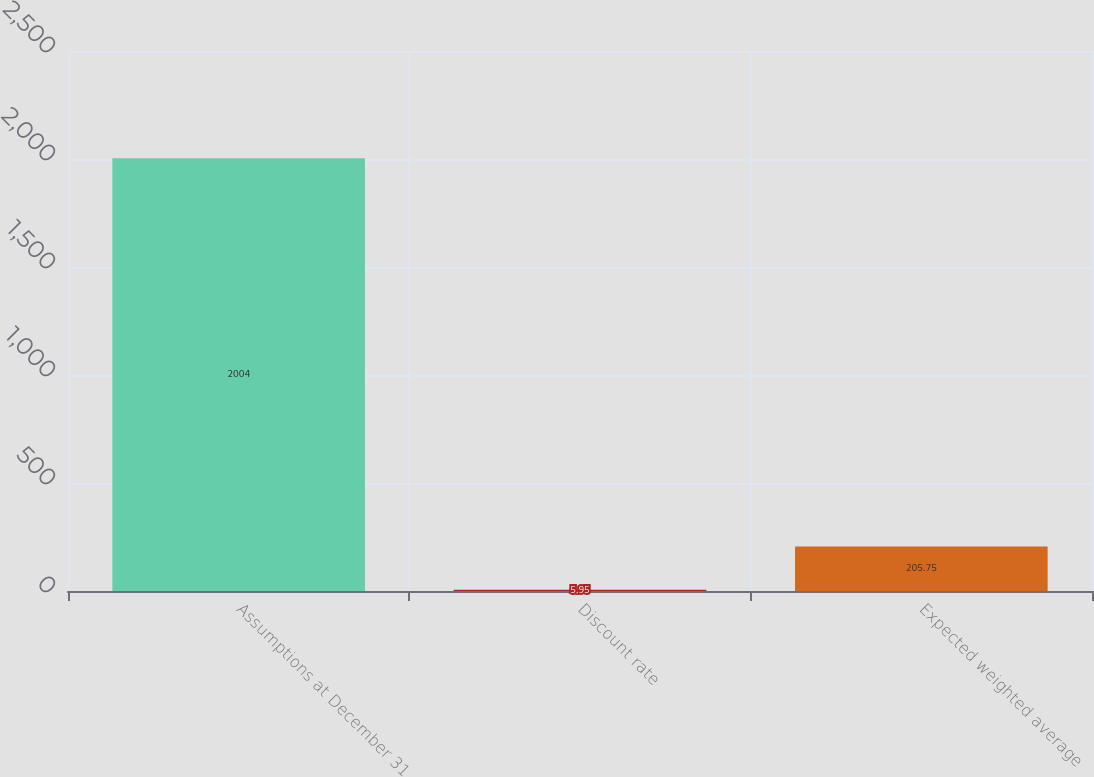Convert chart. <chart><loc_0><loc_0><loc_500><loc_500><bar_chart><fcel>Assumptions at December 31<fcel>Discount rate<fcel>Expected weighted average<nl><fcel>2004<fcel>5.95<fcel>205.75<nl></chart> 